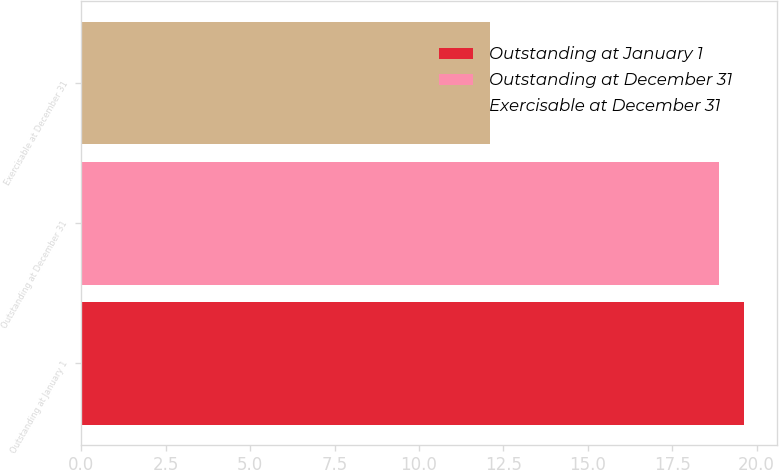Convert chart to OTSL. <chart><loc_0><loc_0><loc_500><loc_500><bar_chart><fcel>Outstanding at January 1<fcel>Outstanding at December 31<fcel>Exercisable at December 31<nl><fcel>19.64<fcel>18.9<fcel>12.1<nl></chart> 